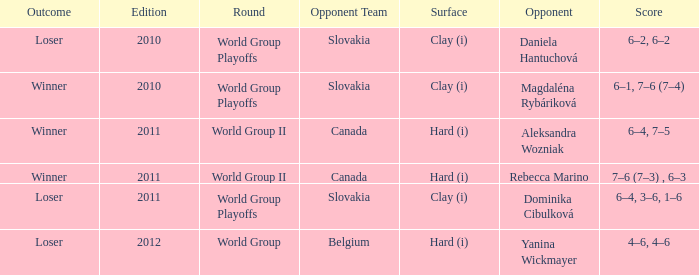What was the score when the rival team was from belgium? 4–6, 4–6. 